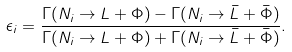<formula> <loc_0><loc_0><loc_500><loc_500>\epsilon _ { i } = \frac { \Gamma ( N _ { i } \rightarrow L + \Phi ) - \Gamma ( N _ { i } \rightarrow { \bar { L } } + { \bar { \Phi } } ) } { \Gamma ( N _ { i } \rightarrow L + \Phi ) + \Gamma ( N _ { i } \rightarrow { \bar { L } } + { \bar { \Phi } } ) } .</formula> 